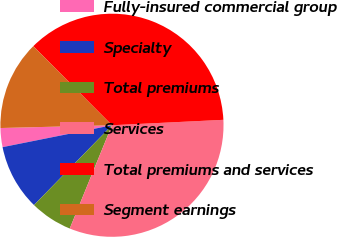Convert chart. <chart><loc_0><loc_0><loc_500><loc_500><pie_chart><fcel>Fully-insured commercial group<fcel>Specialty<fcel>Total premiums<fcel>Services<fcel>Total premiums and services<fcel>Segment earnings<nl><fcel>2.75%<fcel>9.54%<fcel>6.14%<fcel>31.95%<fcel>36.69%<fcel>12.93%<nl></chart> 